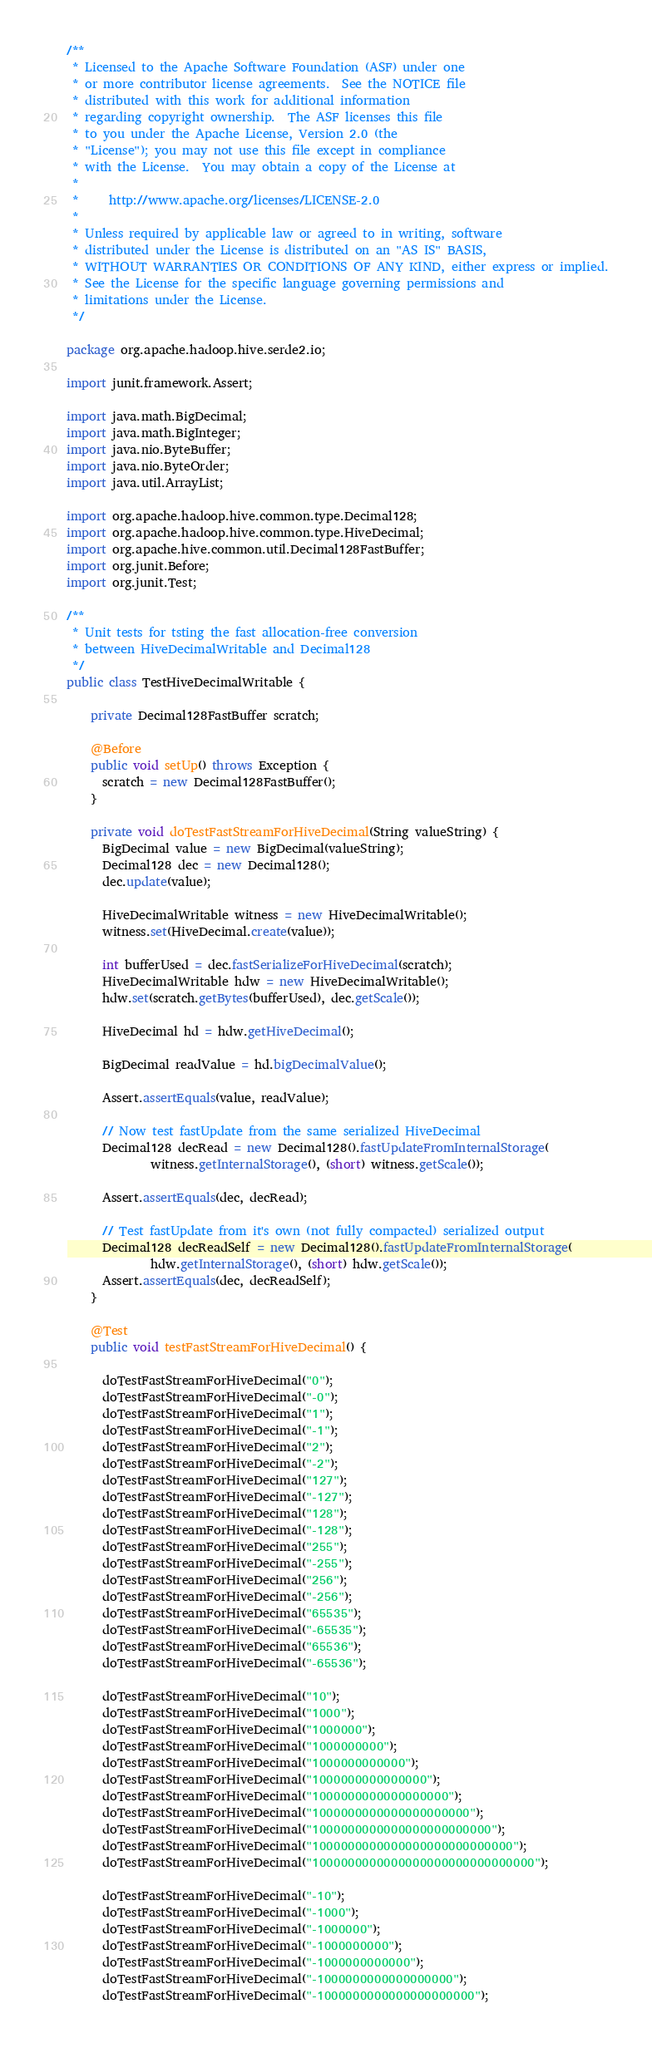Convert code to text. <code><loc_0><loc_0><loc_500><loc_500><_Java_>/**
 * Licensed to the Apache Software Foundation (ASF) under one
 * or more contributor license agreements.  See the NOTICE file
 * distributed with this work for additional information
 * regarding copyright ownership.  The ASF licenses this file
 * to you under the Apache License, Version 2.0 (the
 * "License"); you may not use this file except in compliance
 * with the License.  You may obtain a copy of the License at
 *
 *     http://www.apache.org/licenses/LICENSE-2.0
 *
 * Unless required by applicable law or agreed to in writing, software
 * distributed under the License is distributed on an "AS IS" BASIS,
 * WITHOUT WARRANTIES OR CONDITIONS OF ANY KIND, either express or implied.
 * See the License for the specific language governing permissions and
 * limitations under the License.
 */

package org.apache.hadoop.hive.serde2.io;

import junit.framework.Assert;

import java.math.BigDecimal;
import java.math.BigInteger;
import java.nio.ByteBuffer;
import java.nio.ByteOrder;
import java.util.ArrayList;

import org.apache.hadoop.hive.common.type.Decimal128;
import org.apache.hadoop.hive.common.type.HiveDecimal;
import org.apache.hive.common.util.Decimal128FastBuffer;
import org.junit.Before;
import org.junit.Test;

/**
 * Unit tests for tsting the fast allocation-free conversion
 * between HiveDecimalWritable and Decimal128
 */
public class TestHiveDecimalWritable {

    private Decimal128FastBuffer scratch;

    @Before
    public void setUp() throws Exception {
      scratch = new Decimal128FastBuffer();
    }

    private void doTestFastStreamForHiveDecimal(String valueString) {
      BigDecimal value = new BigDecimal(valueString);
      Decimal128 dec = new Decimal128();
      dec.update(value);

      HiveDecimalWritable witness = new HiveDecimalWritable();
      witness.set(HiveDecimal.create(value));

      int bufferUsed = dec.fastSerializeForHiveDecimal(scratch);
      HiveDecimalWritable hdw = new HiveDecimalWritable();
      hdw.set(scratch.getBytes(bufferUsed), dec.getScale());

      HiveDecimal hd = hdw.getHiveDecimal();

      BigDecimal readValue = hd.bigDecimalValue();

      Assert.assertEquals(value, readValue);

      // Now test fastUpdate from the same serialized HiveDecimal
      Decimal128 decRead = new Decimal128().fastUpdateFromInternalStorage(
              witness.getInternalStorage(), (short) witness.getScale());

      Assert.assertEquals(dec, decRead);

      // Test fastUpdate from it's own (not fully compacted) serialized output
      Decimal128 decReadSelf = new Decimal128().fastUpdateFromInternalStorage(
              hdw.getInternalStorage(), (short) hdw.getScale());
      Assert.assertEquals(dec, decReadSelf);
    }

    @Test
    public void testFastStreamForHiveDecimal() {

      doTestFastStreamForHiveDecimal("0");
      doTestFastStreamForHiveDecimal("-0");
      doTestFastStreamForHiveDecimal("1");
      doTestFastStreamForHiveDecimal("-1");
      doTestFastStreamForHiveDecimal("2");
      doTestFastStreamForHiveDecimal("-2");
      doTestFastStreamForHiveDecimal("127");
      doTestFastStreamForHiveDecimal("-127");
      doTestFastStreamForHiveDecimal("128");
      doTestFastStreamForHiveDecimal("-128");
      doTestFastStreamForHiveDecimal("255");
      doTestFastStreamForHiveDecimal("-255");
      doTestFastStreamForHiveDecimal("256");
      doTestFastStreamForHiveDecimal("-256");
      doTestFastStreamForHiveDecimal("65535");
      doTestFastStreamForHiveDecimal("-65535");
      doTestFastStreamForHiveDecimal("65536");
      doTestFastStreamForHiveDecimal("-65536");

      doTestFastStreamForHiveDecimal("10");
      doTestFastStreamForHiveDecimal("1000");
      doTestFastStreamForHiveDecimal("1000000");
      doTestFastStreamForHiveDecimal("1000000000");
      doTestFastStreamForHiveDecimal("1000000000000");
      doTestFastStreamForHiveDecimal("1000000000000000");
      doTestFastStreamForHiveDecimal("1000000000000000000");
      doTestFastStreamForHiveDecimal("1000000000000000000000");
      doTestFastStreamForHiveDecimal("1000000000000000000000000");
      doTestFastStreamForHiveDecimal("1000000000000000000000000000");
      doTestFastStreamForHiveDecimal("1000000000000000000000000000000");

      doTestFastStreamForHiveDecimal("-10");
      doTestFastStreamForHiveDecimal("-1000");
      doTestFastStreamForHiveDecimal("-1000000");
      doTestFastStreamForHiveDecimal("-1000000000");
      doTestFastStreamForHiveDecimal("-1000000000000");
      doTestFastStreamForHiveDecimal("-1000000000000000000");
      doTestFastStreamForHiveDecimal("-1000000000000000000000");</code> 